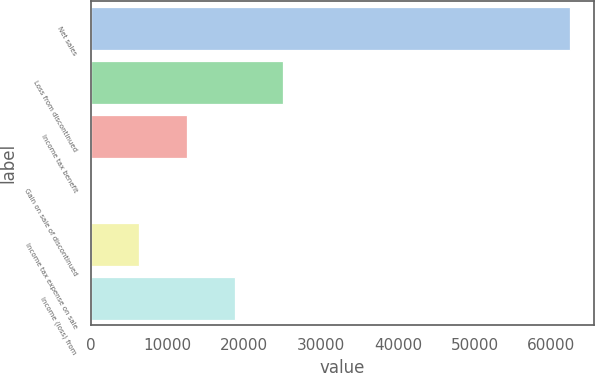Convert chart. <chart><loc_0><loc_0><loc_500><loc_500><bar_chart><fcel>Net sales<fcel>Loss from discontinued<fcel>Income tax benefit<fcel>Gain on sale of discontinued<fcel>Income tax expense on sale<fcel>Income (loss) from<nl><fcel>62489<fcel>24996.1<fcel>12498.5<fcel>0.82<fcel>6249.64<fcel>18747.3<nl></chart> 